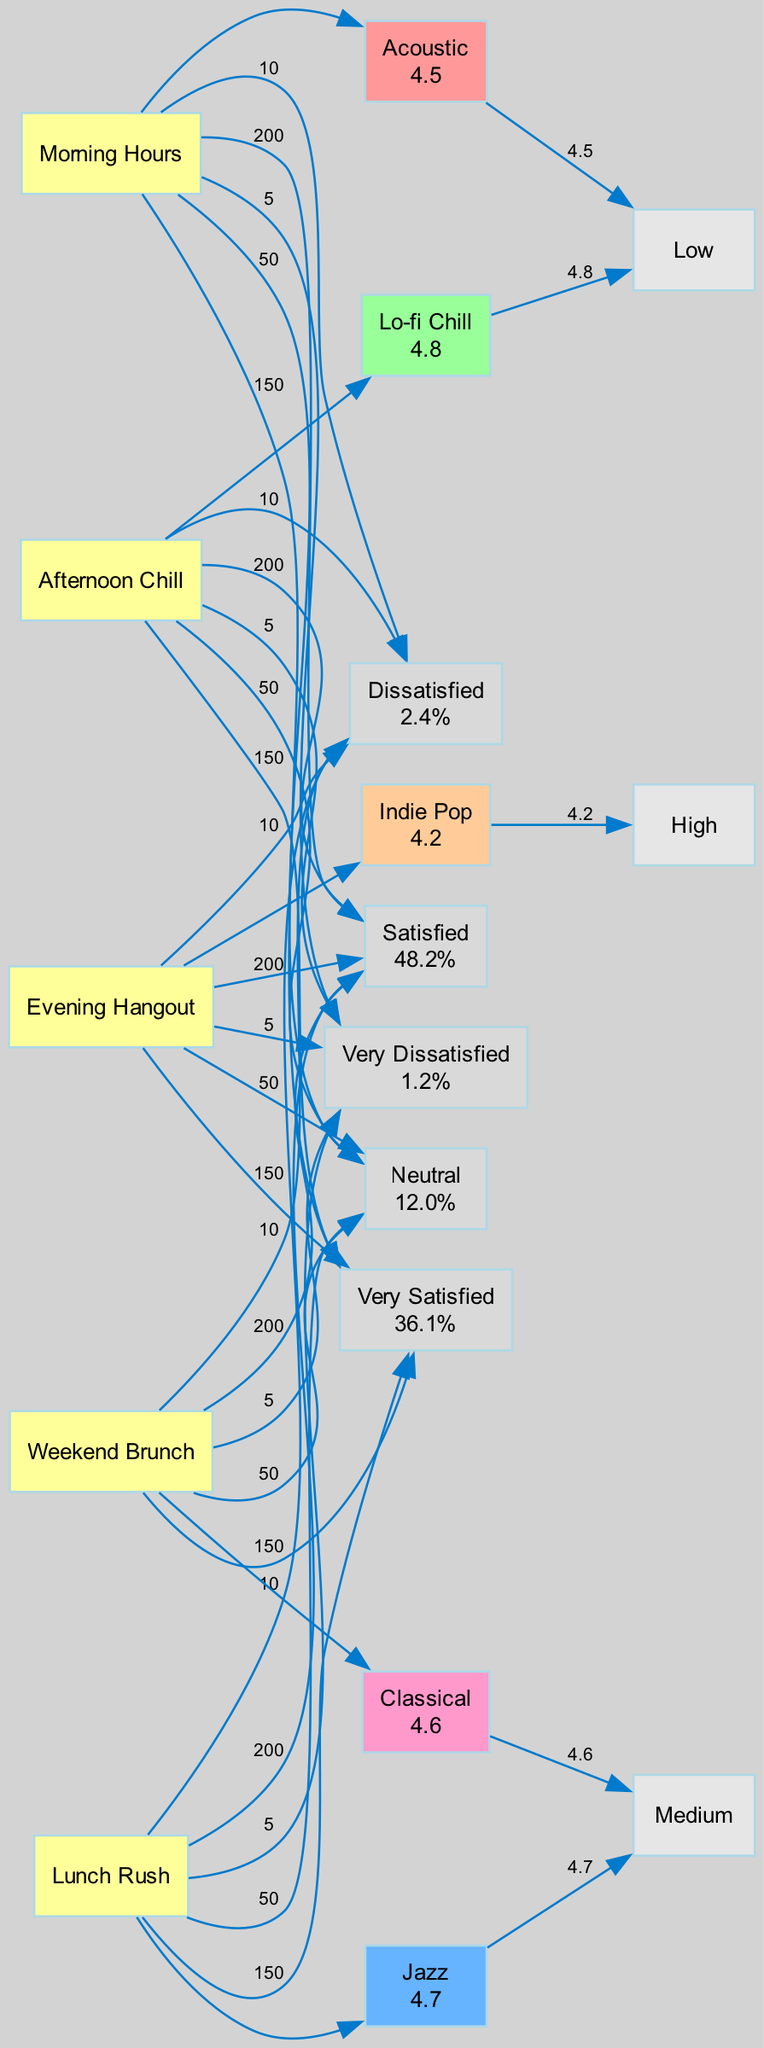What is the satisfaction rating for Lo-fi Chill? The satisfaction rating for Lo-fi Chill is stated directly on the node representing this music type in the diagram. It shows a value of 4.8.
Answer: 4.8 Which music type is associated with the Evening Hangout setting? The diagram indicates the music type linked to the Evening Hangout setting. By tracing the edge from the Evening Hangout node, I can see it connects to the Indie Pop node, indicating that this is the associated music type.
Answer: Indie Pop How many total feedback counts are represented in the diagram? To find the total feedback counts, I need to sum the counts of all feedback types shown in the diagram. According to the provided data, the total is 150 + 200 + 50 + 10 + 5 = 415.
Answer: 415 What volume level is associated with Classical music? By examining the node for Classical music in the diagram, I can identify the volume level stated as "Medium." This is indicated next to the music type node.
Answer: Medium What percentage of customer feedback falls under "Very Satisfied"? The diagram shows that 150 customers provided the "Very Satisfied" feedback. To find the percentage, I can use the formula (150 / 415) * 100, which equals approximately 36.1%.
Answer: 36.1% Which setting has the highest satisfaction rating among its music type? To determine this, I need to compare the satisfaction ratings of all music types linked to different settings. The ratings are: 4.5 (Acoustic), 4.7 (Jazz), 4.8 (Lo-fi Chill), 4.2 (Indie Pop), and 4.6 (Classical). The highest is 4.8 for Lo-fi Chill which is linked to the Afternoon Chill setting.
Answer: Afternoon Chill How many different music types are displayed in the diagram? I can count the number of unique music types by examining the nodes in the music types section of the diagram. There are five distinct types: Acoustic, Jazz, Lo-fi Chill, Indie Pop, and Classical, which gives a total of five.
Answer: 5 Which feedback type corresponds to a count of 10? Looking at the feedback counts provided in the diagram, I can see that the count of 10 is linked to the feedback type "Dissatisfied." This is clearly indicated by the respective node.
Answer: Dissatisfied Which music genre has a low volume level and a satisfaction rating above 4.5? To answer this, I need to review the nodes representing music types with low volume levels. The relevant types are Acoustic (4.5) and Lo-fi Chill (4.8). Since Lo-fi Chill is the only one with a satisfaction rating above 4.5, it fulfills the criteria.
Answer: Lo-fi Chill 